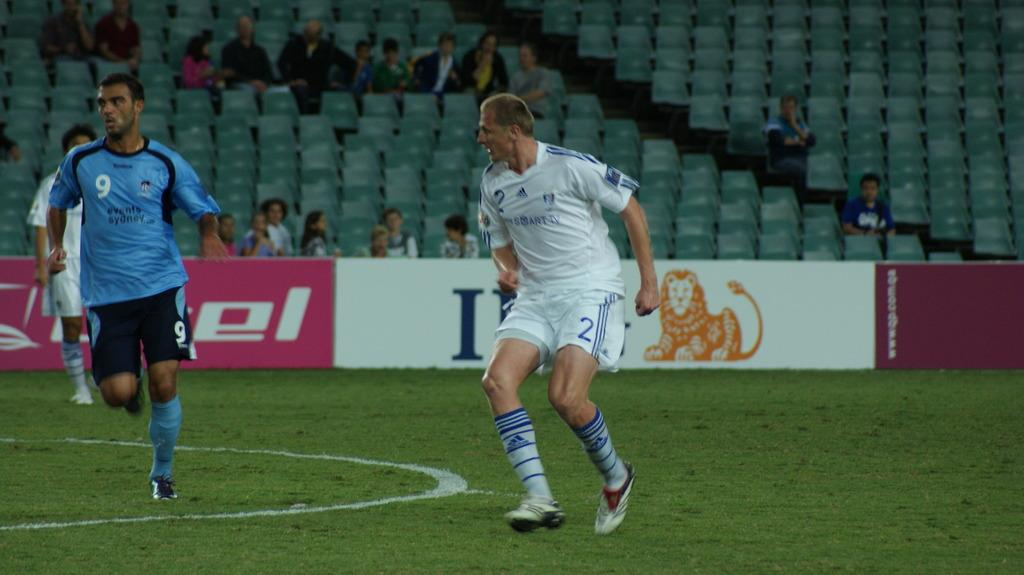<image>
Share a concise interpretation of the image provided. Two teams playing on a soccer field, with a picture of a lion in the background and the team numbers is #2 and #9 for the other team. 